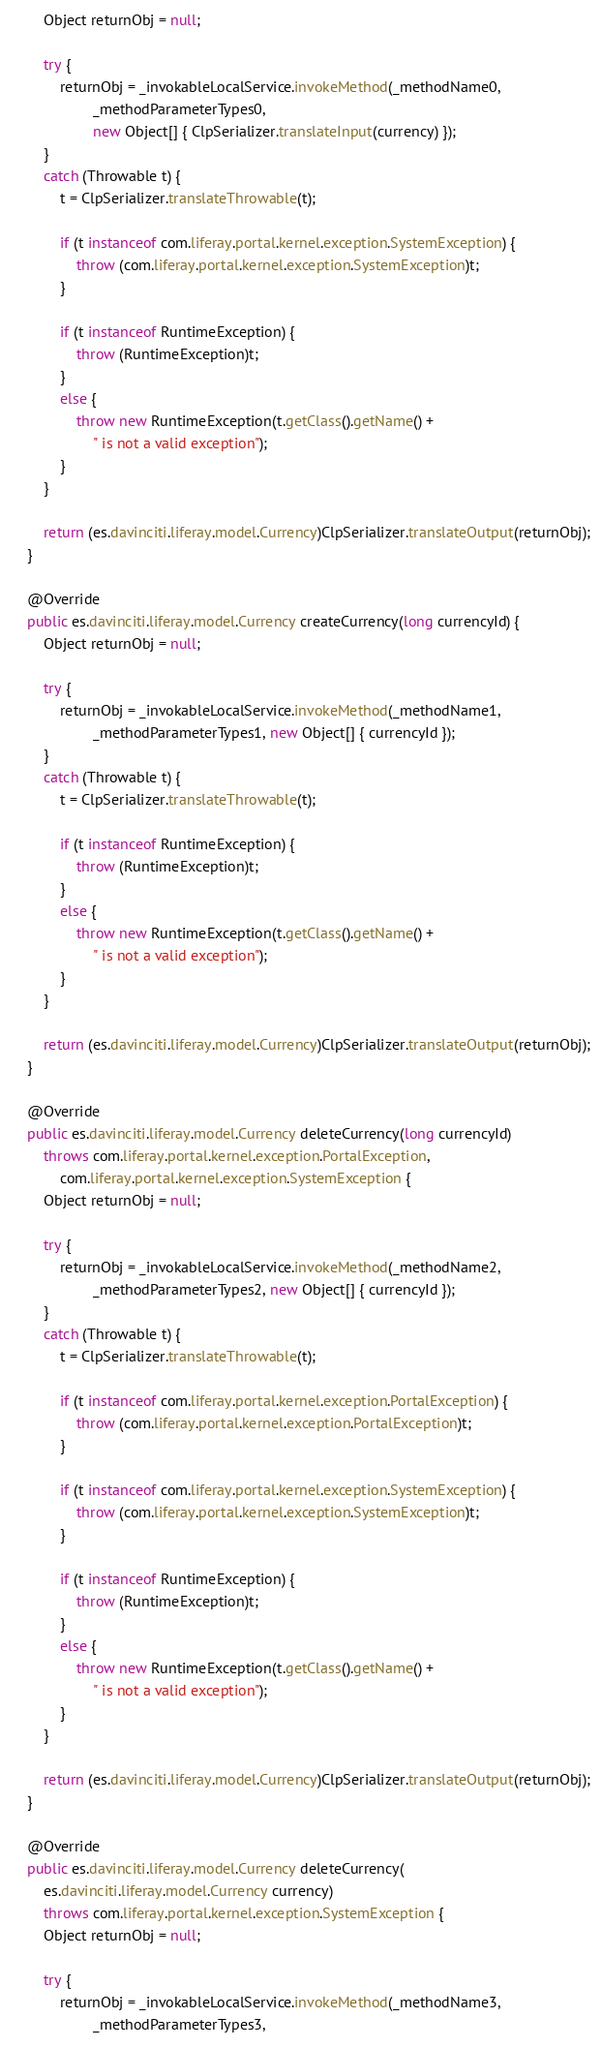<code> <loc_0><loc_0><loc_500><loc_500><_Java_>		Object returnObj = null;

		try {
			returnObj = _invokableLocalService.invokeMethod(_methodName0,
					_methodParameterTypes0,
					new Object[] { ClpSerializer.translateInput(currency) });
		}
		catch (Throwable t) {
			t = ClpSerializer.translateThrowable(t);

			if (t instanceof com.liferay.portal.kernel.exception.SystemException) {
				throw (com.liferay.portal.kernel.exception.SystemException)t;
			}

			if (t instanceof RuntimeException) {
				throw (RuntimeException)t;
			}
			else {
				throw new RuntimeException(t.getClass().getName() +
					" is not a valid exception");
			}
		}

		return (es.davinciti.liferay.model.Currency)ClpSerializer.translateOutput(returnObj);
	}

	@Override
	public es.davinciti.liferay.model.Currency createCurrency(long currencyId) {
		Object returnObj = null;

		try {
			returnObj = _invokableLocalService.invokeMethod(_methodName1,
					_methodParameterTypes1, new Object[] { currencyId });
		}
		catch (Throwable t) {
			t = ClpSerializer.translateThrowable(t);

			if (t instanceof RuntimeException) {
				throw (RuntimeException)t;
			}
			else {
				throw new RuntimeException(t.getClass().getName() +
					" is not a valid exception");
			}
		}

		return (es.davinciti.liferay.model.Currency)ClpSerializer.translateOutput(returnObj);
	}

	@Override
	public es.davinciti.liferay.model.Currency deleteCurrency(long currencyId)
		throws com.liferay.portal.kernel.exception.PortalException,
			com.liferay.portal.kernel.exception.SystemException {
		Object returnObj = null;

		try {
			returnObj = _invokableLocalService.invokeMethod(_methodName2,
					_methodParameterTypes2, new Object[] { currencyId });
		}
		catch (Throwable t) {
			t = ClpSerializer.translateThrowable(t);

			if (t instanceof com.liferay.portal.kernel.exception.PortalException) {
				throw (com.liferay.portal.kernel.exception.PortalException)t;
			}

			if (t instanceof com.liferay.portal.kernel.exception.SystemException) {
				throw (com.liferay.portal.kernel.exception.SystemException)t;
			}

			if (t instanceof RuntimeException) {
				throw (RuntimeException)t;
			}
			else {
				throw new RuntimeException(t.getClass().getName() +
					" is not a valid exception");
			}
		}

		return (es.davinciti.liferay.model.Currency)ClpSerializer.translateOutput(returnObj);
	}

	@Override
	public es.davinciti.liferay.model.Currency deleteCurrency(
		es.davinciti.liferay.model.Currency currency)
		throws com.liferay.portal.kernel.exception.SystemException {
		Object returnObj = null;

		try {
			returnObj = _invokableLocalService.invokeMethod(_methodName3,
					_methodParameterTypes3,</code> 